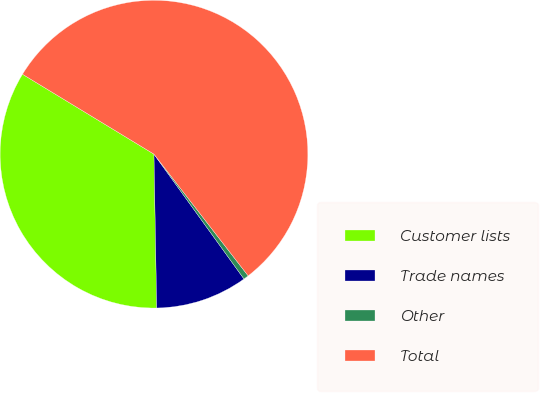Convert chart. <chart><loc_0><loc_0><loc_500><loc_500><pie_chart><fcel>Customer lists<fcel>Trade names<fcel>Other<fcel>Total<nl><fcel>33.98%<fcel>9.66%<fcel>0.54%<fcel>55.83%<nl></chart> 